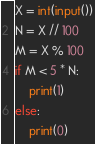<code> <loc_0><loc_0><loc_500><loc_500><_Python_>X = int(input())
N = X // 100
M = X % 100
if M < 5 * N:
    print(1)
else:
    print(0)</code> 